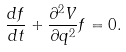Convert formula to latex. <formula><loc_0><loc_0><loc_500><loc_500>\frac { d f } { d t } + \frac { \partial ^ { 2 } V } { \partial q ^ { 2 } } f = 0 .</formula> 